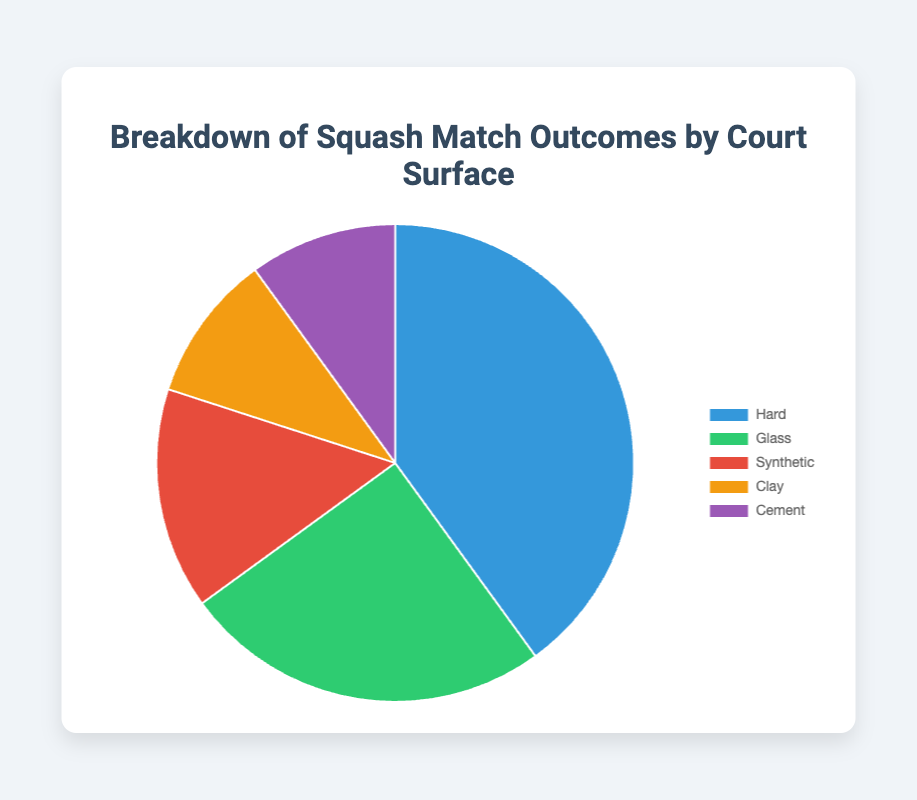What percentage of matches were played on hard courts combined with synthetic courts? To find the total percentage of matches played on hard and synthetic courts, add their individual percentages: 40% (hard) + 15% (synthetic) = 55%.
Answer: 55% Which court surface corresponds to the green segment of the pie chart? The green segment in the pie chart is labeled as "Glass," which represents court surface outcomes on glass courts.
Answer: Glass How does the percentage of matches played on clay courts compare to those played on cement courts? Both clay and cement courts have the same percentage of matches played, which is 10%. Thus, they are equal.
Answer: Equal What is the overall percentage of matches played on surfaces other than hard courts? To find the overall percentage of non-hard court matches, sum the percentages of glass, synthetic, clay, and cement courts: 25% + 15% + 10% + 10% = 60%.
Answer: 60% Which court surface has the smallest percentage of matches played, and what is this percentage? Both clay and cement courts have the smallest percentage, with each having 10% of matches played.
Answer: Clay and Cement, 10% What is the difference in match percentages between the most and least frequently used court surfaces? The most frequently used court surface is hard (40%), and the least frequently used are clay and cement (each 10%). The difference is 40% - 10% = 30%.
Answer: 30% If you combine the percentages of matches on glass and synthetic courts, what fraction of the total percentage do they represent? First, combine the percentages: 25% (glass) + 15% (synthetic) = 40%. Since the total is 100%, the fraction is 40/100 or 2/5.
Answer: 2/5 Compare the percentage of matches played on synthetic courts to those on glass courts. The percentage of matches played on synthetic courts (15%) is 10% less than those played on glass courts (25%).
Answer: Synthetic courts 10% less What is the total percentage of matches played on non-glass courts? Sum the percentages of matches played on hard, synthetic, clay, and cement courts: 40% + 15% + 10% + 10% = 75%.
Answer: 75% Which court surface is represented by the blue segment of the pie chart, and what is the corresponding percentage? The blue segment is labeled as "Hard," representing 40% of the matches played on hard courts.
Answer: Hard, 40% 